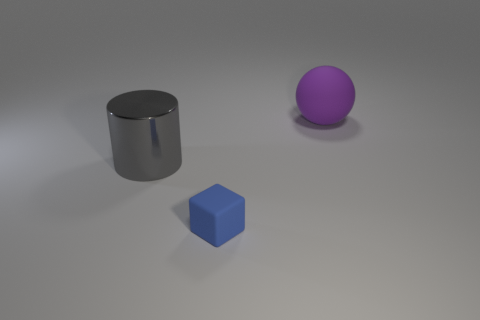Subtract all purple cylinders. Subtract all blue balls. How many cylinders are left? 1 Add 2 large metallic cylinders. How many objects exist? 5 Subtract all blocks. How many objects are left? 2 Subtract 0 yellow blocks. How many objects are left? 3 Subtract all big purple cubes. Subtract all gray cylinders. How many objects are left? 2 Add 1 big gray things. How many big gray things are left? 2 Add 1 purple balls. How many purple balls exist? 2 